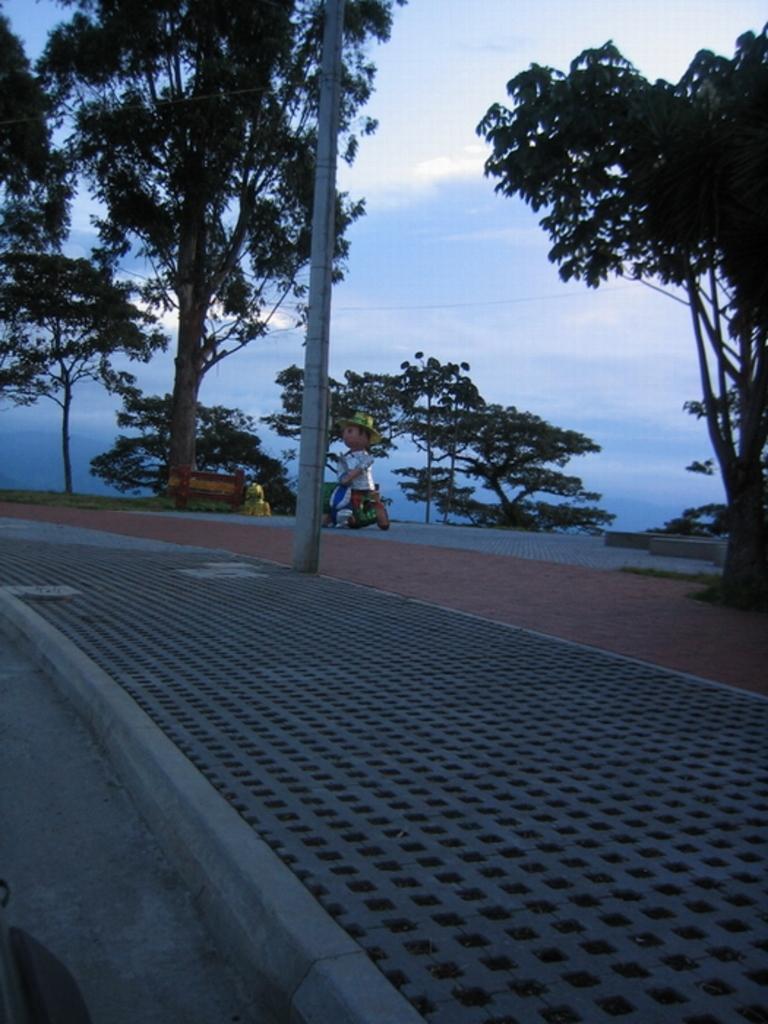In one or two sentences, can you explain what this image depicts? It is the footpath, these are the green trees. In the middle it is the sky. 